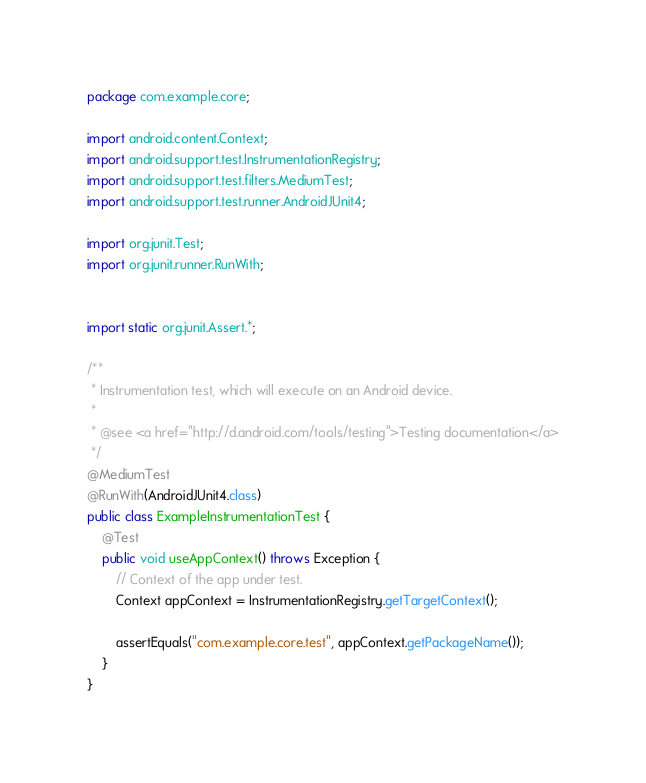Convert code to text. <code><loc_0><loc_0><loc_500><loc_500><_Java_>package com.example.core;

import android.content.Context;
import android.support.test.InstrumentationRegistry;
import android.support.test.filters.MediumTest;
import android.support.test.runner.AndroidJUnit4;

import org.junit.Test;
import org.junit.runner.RunWith;


import static org.junit.Assert.*;

/**
 * Instrumentation test, which will execute on an Android device.
 *
 * @see <a href="http://d.android.com/tools/testing">Testing documentation</a>
 */
@MediumTest
@RunWith(AndroidJUnit4.class)
public class ExampleInstrumentationTest {
    @Test
    public void useAppContext() throws Exception {
        // Context of the app under test.
        Context appContext = InstrumentationRegistry.getTargetContext();

        assertEquals("com.example.core.test", appContext.getPackageName());
    }
}</code> 